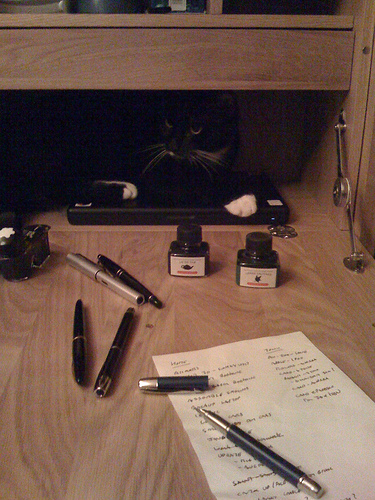<image>
Can you confirm if the ink pen is to the right of the ink jar? No. The ink pen is not to the right of the ink jar. The horizontal positioning shows a different relationship. 